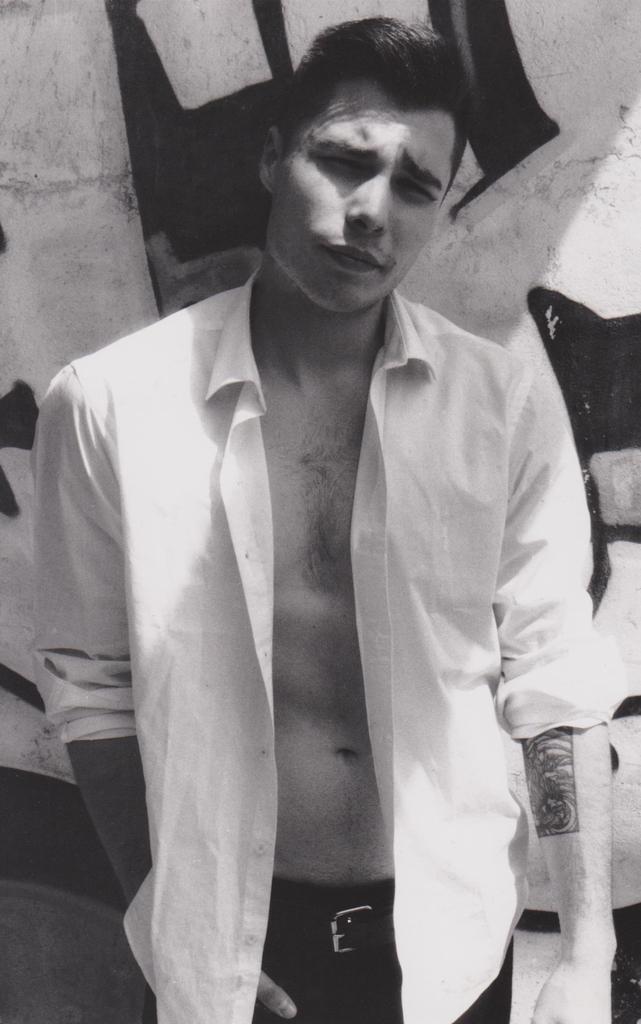Could you give a brief overview of what you see in this image? This is a black and white image. In this image we can see a man. On the hand of the man there is tattoo. In the background there is a wall. 